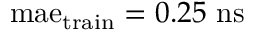<formula> <loc_0><loc_0><loc_500><loc_500>m a e _ { t r a i n } = 0 . 2 5 n s</formula> 